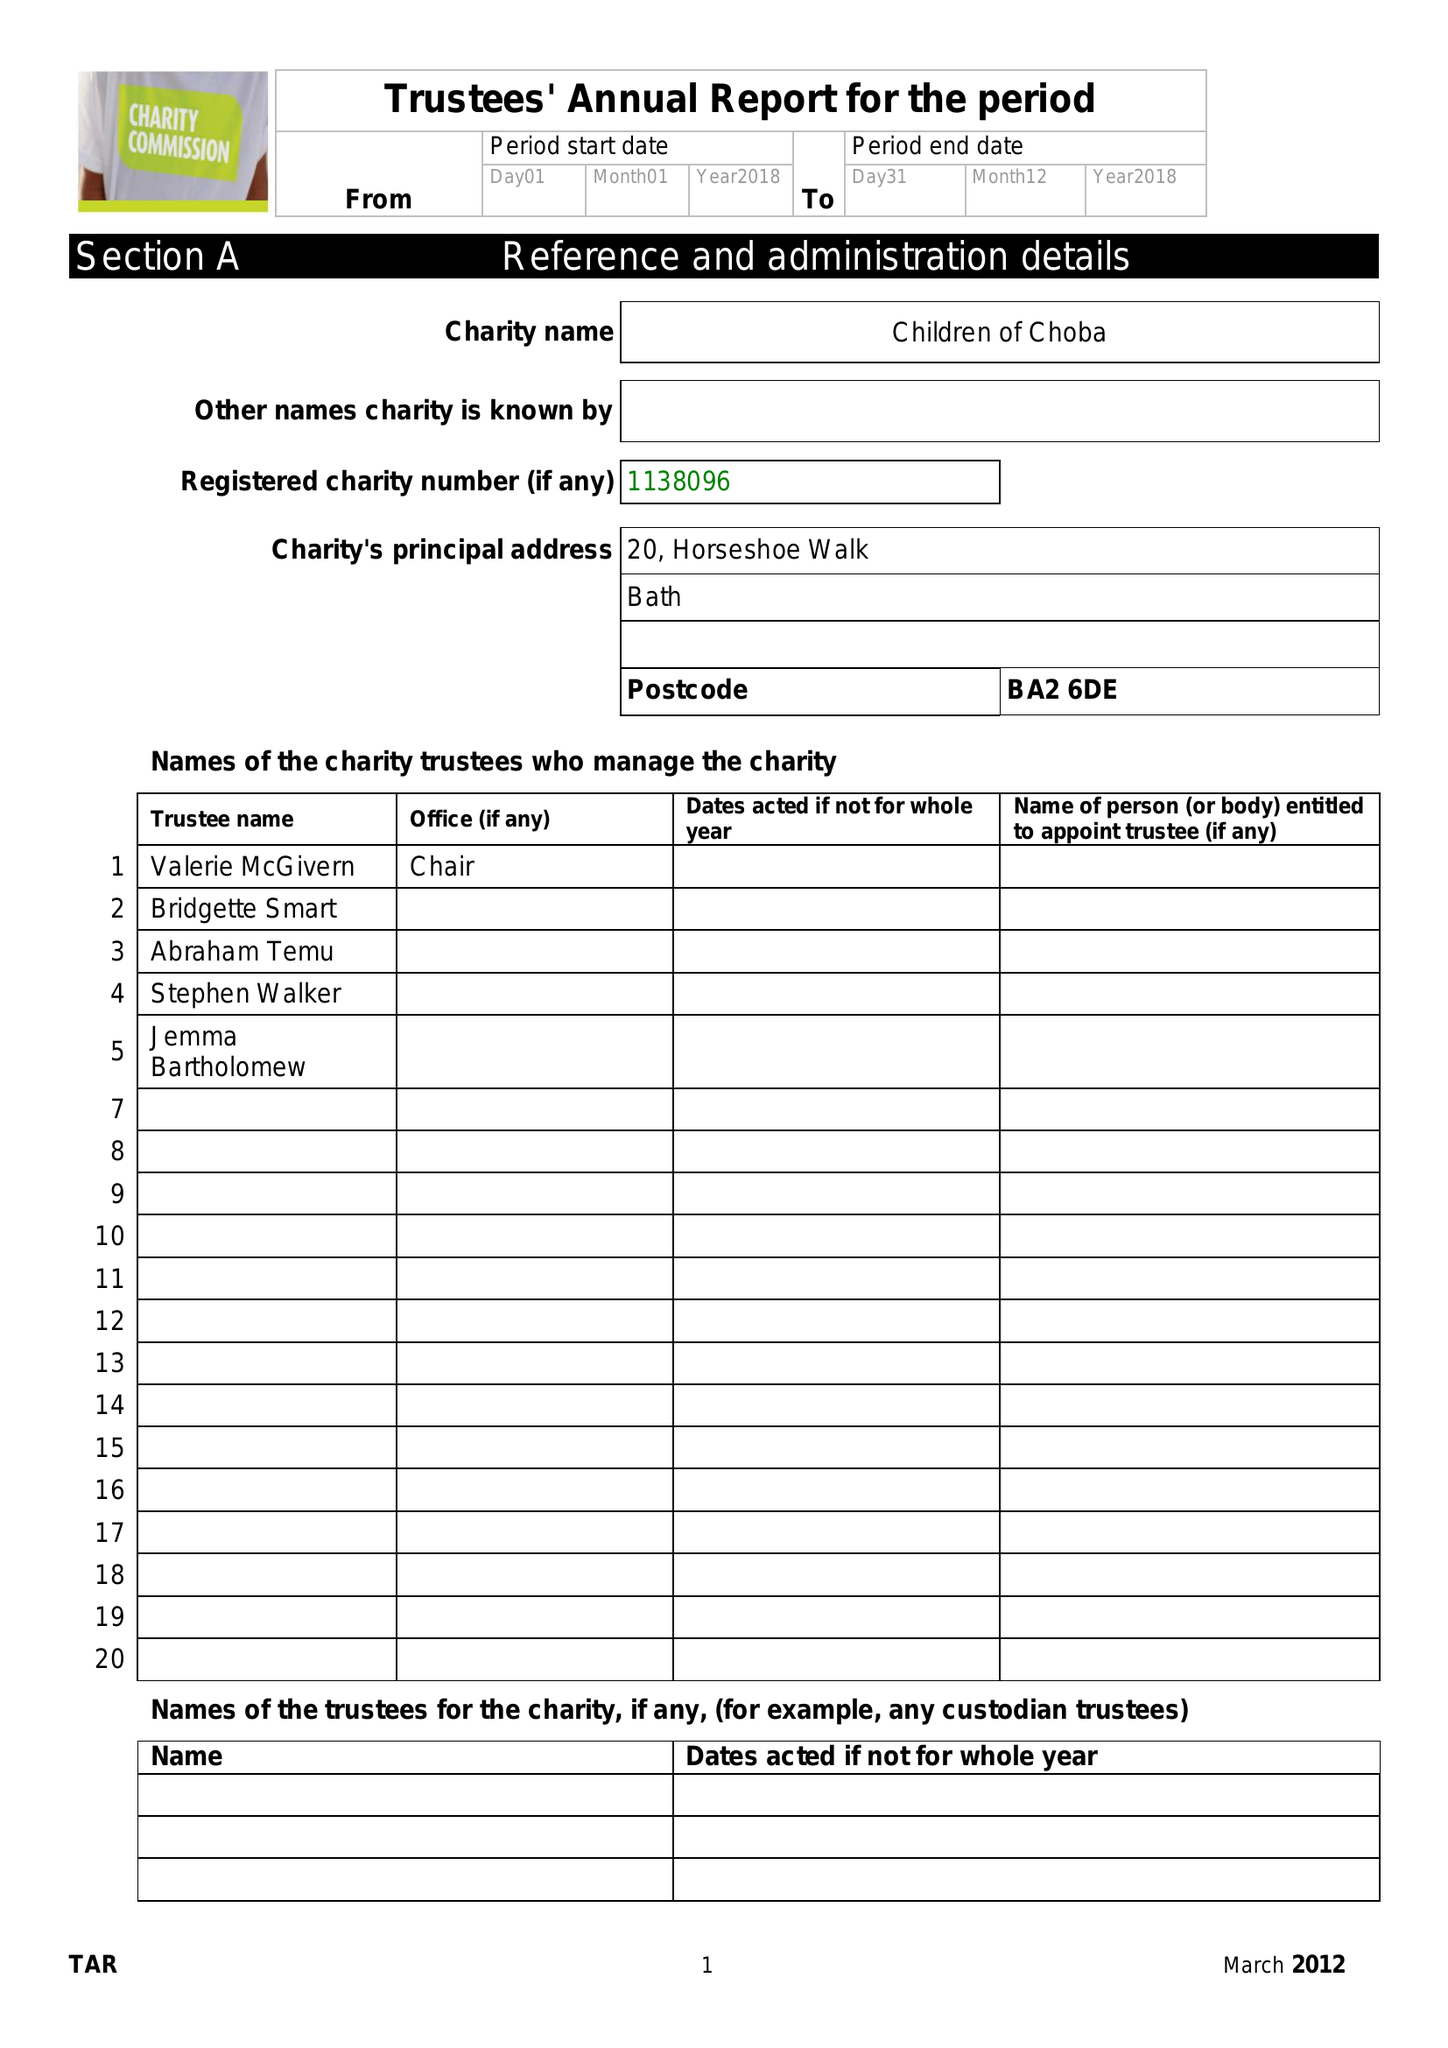What is the value for the address__postcode?
Answer the question using a single word or phrase. BA2 6DE 